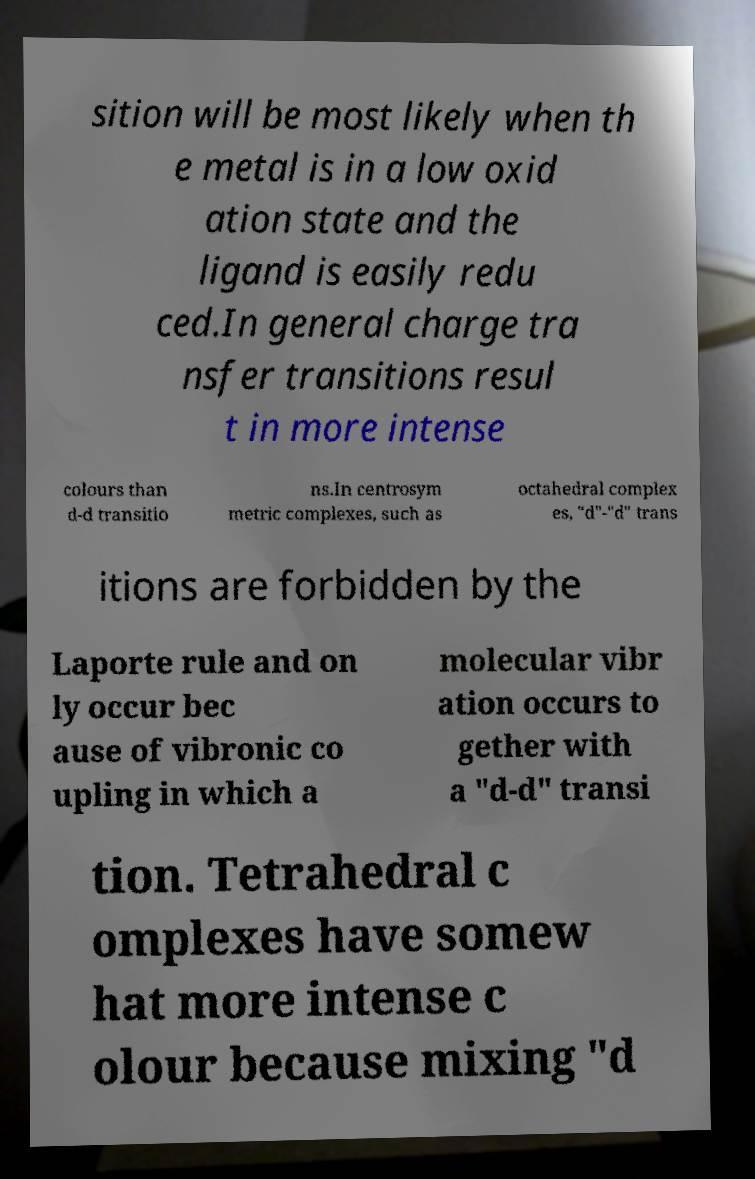Could you assist in decoding the text presented in this image and type it out clearly? sition will be most likely when th e metal is in a low oxid ation state and the ligand is easily redu ced.In general charge tra nsfer transitions resul t in more intense colours than d-d transitio ns.In centrosym metric complexes, such as octahedral complex es, "d"-"d" trans itions are forbidden by the Laporte rule and on ly occur bec ause of vibronic co upling in which a molecular vibr ation occurs to gether with a "d-d" transi tion. Tetrahedral c omplexes have somew hat more intense c olour because mixing "d 